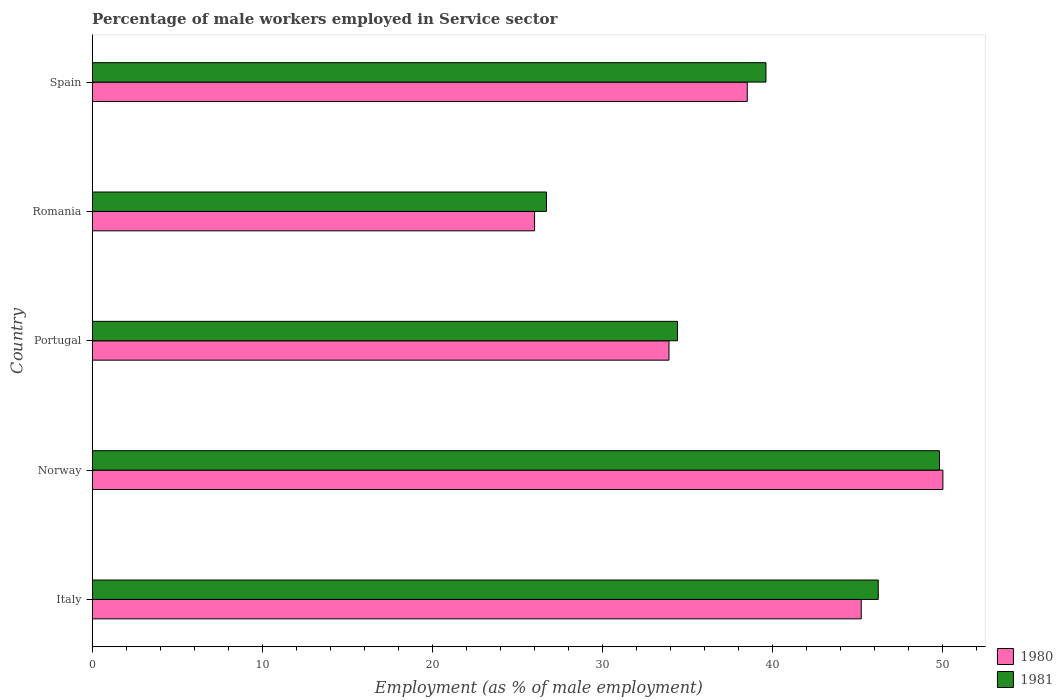How many different coloured bars are there?
Keep it short and to the point. 2. Are the number of bars per tick equal to the number of legend labels?
Offer a very short reply. Yes. How many bars are there on the 3rd tick from the top?
Your answer should be very brief. 2. What is the label of the 3rd group of bars from the top?
Provide a short and direct response. Portugal. In how many cases, is the number of bars for a given country not equal to the number of legend labels?
Ensure brevity in your answer.  0. What is the percentage of male workers employed in Service sector in 1980 in Spain?
Your response must be concise. 38.5. Across all countries, what is the minimum percentage of male workers employed in Service sector in 1980?
Your response must be concise. 26. In which country was the percentage of male workers employed in Service sector in 1981 minimum?
Ensure brevity in your answer.  Romania. What is the total percentage of male workers employed in Service sector in 1980 in the graph?
Ensure brevity in your answer.  193.6. What is the difference between the percentage of male workers employed in Service sector in 1981 in Portugal and that in Romania?
Give a very brief answer. 7.7. What is the difference between the percentage of male workers employed in Service sector in 1981 in Spain and the percentage of male workers employed in Service sector in 1980 in Italy?
Make the answer very short. -5.6. What is the average percentage of male workers employed in Service sector in 1980 per country?
Make the answer very short. 38.72. What is the difference between the percentage of male workers employed in Service sector in 1981 and percentage of male workers employed in Service sector in 1980 in Spain?
Your answer should be very brief. 1.1. In how many countries, is the percentage of male workers employed in Service sector in 1980 greater than 30 %?
Make the answer very short. 4. What is the ratio of the percentage of male workers employed in Service sector in 1980 in Portugal to that in Romania?
Give a very brief answer. 1.3. Is the percentage of male workers employed in Service sector in 1980 in Italy less than that in Spain?
Provide a succinct answer. No. Is the difference between the percentage of male workers employed in Service sector in 1981 in Italy and Norway greater than the difference between the percentage of male workers employed in Service sector in 1980 in Italy and Norway?
Offer a very short reply. Yes. What is the difference between the highest and the second highest percentage of male workers employed in Service sector in 1981?
Your answer should be very brief. 3.6. What is the difference between the highest and the lowest percentage of male workers employed in Service sector in 1981?
Give a very brief answer. 23.1. What does the 1st bar from the top in Italy represents?
Your response must be concise. 1981. What does the 2nd bar from the bottom in Portugal represents?
Give a very brief answer. 1981. Are the values on the major ticks of X-axis written in scientific E-notation?
Offer a very short reply. No. Does the graph contain any zero values?
Give a very brief answer. No. Does the graph contain grids?
Provide a succinct answer. No. What is the title of the graph?
Your response must be concise. Percentage of male workers employed in Service sector. What is the label or title of the X-axis?
Ensure brevity in your answer.  Employment (as % of male employment). What is the label or title of the Y-axis?
Your response must be concise. Country. What is the Employment (as % of male employment) in 1980 in Italy?
Offer a very short reply. 45.2. What is the Employment (as % of male employment) of 1981 in Italy?
Make the answer very short. 46.2. What is the Employment (as % of male employment) of 1981 in Norway?
Your answer should be compact. 49.8. What is the Employment (as % of male employment) in 1980 in Portugal?
Your answer should be very brief. 33.9. What is the Employment (as % of male employment) of 1981 in Portugal?
Keep it short and to the point. 34.4. What is the Employment (as % of male employment) of 1980 in Romania?
Give a very brief answer. 26. What is the Employment (as % of male employment) in 1981 in Romania?
Keep it short and to the point. 26.7. What is the Employment (as % of male employment) in 1980 in Spain?
Offer a terse response. 38.5. What is the Employment (as % of male employment) in 1981 in Spain?
Offer a terse response. 39.6. Across all countries, what is the maximum Employment (as % of male employment) of 1981?
Provide a succinct answer. 49.8. Across all countries, what is the minimum Employment (as % of male employment) in 1981?
Provide a short and direct response. 26.7. What is the total Employment (as % of male employment) of 1980 in the graph?
Ensure brevity in your answer.  193.6. What is the total Employment (as % of male employment) in 1981 in the graph?
Offer a very short reply. 196.7. What is the difference between the Employment (as % of male employment) of 1980 in Italy and that in Portugal?
Your answer should be very brief. 11.3. What is the difference between the Employment (as % of male employment) in 1981 in Italy and that in Portugal?
Offer a very short reply. 11.8. What is the difference between the Employment (as % of male employment) of 1980 in Italy and that in Romania?
Your answer should be compact. 19.2. What is the difference between the Employment (as % of male employment) in 1980 in Norway and that in Portugal?
Provide a succinct answer. 16.1. What is the difference between the Employment (as % of male employment) of 1981 in Norway and that in Portugal?
Your answer should be very brief. 15.4. What is the difference between the Employment (as % of male employment) in 1980 in Norway and that in Romania?
Ensure brevity in your answer.  24. What is the difference between the Employment (as % of male employment) in 1981 in Norway and that in Romania?
Make the answer very short. 23.1. What is the difference between the Employment (as % of male employment) of 1980 in Portugal and that in Romania?
Offer a very short reply. 7.9. What is the difference between the Employment (as % of male employment) of 1981 in Portugal and that in Spain?
Your response must be concise. -5.2. What is the difference between the Employment (as % of male employment) in 1980 in Romania and that in Spain?
Your answer should be very brief. -12.5. What is the difference between the Employment (as % of male employment) of 1981 in Romania and that in Spain?
Keep it short and to the point. -12.9. What is the difference between the Employment (as % of male employment) in 1980 in Italy and the Employment (as % of male employment) in 1981 in Portugal?
Your answer should be compact. 10.8. What is the difference between the Employment (as % of male employment) of 1980 in Italy and the Employment (as % of male employment) of 1981 in Romania?
Offer a terse response. 18.5. What is the difference between the Employment (as % of male employment) in 1980 in Italy and the Employment (as % of male employment) in 1981 in Spain?
Keep it short and to the point. 5.6. What is the difference between the Employment (as % of male employment) in 1980 in Norway and the Employment (as % of male employment) in 1981 in Portugal?
Your answer should be very brief. 15.6. What is the difference between the Employment (as % of male employment) in 1980 in Norway and the Employment (as % of male employment) in 1981 in Romania?
Offer a terse response. 23.3. What is the difference between the Employment (as % of male employment) in 1980 in Portugal and the Employment (as % of male employment) in 1981 in Spain?
Make the answer very short. -5.7. What is the average Employment (as % of male employment) in 1980 per country?
Your answer should be very brief. 38.72. What is the average Employment (as % of male employment) of 1981 per country?
Offer a very short reply. 39.34. What is the difference between the Employment (as % of male employment) of 1980 and Employment (as % of male employment) of 1981 in Spain?
Offer a terse response. -1.1. What is the ratio of the Employment (as % of male employment) in 1980 in Italy to that in Norway?
Provide a short and direct response. 0.9. What is the ratio of the Employment (as % of male employment) of 1981 in Italy to that in Norway?
Keep it short and to the point. 0.93. What is the ratio of the Employment (as % of male employment) in 1981 in Italy to that in Portugal?
Your answer should be very brief. 1.34. What is the ratio of the Employment (as % of male employment) in 1980 in Italy to that in Romania?
Offer a very short reply. 1.74. What is the ratio of the Employment (as % of male employment) of 1981 in Italy to that in Romania?
Give a very brief answer. 1.73. What is the ratio of the Employment (as % of male employment) of 1980 in Italy to that in Spain?
Ensure brevity in your answer.  1.17. What is the ratio of the Employment (as % of male employment) of 1980 in Norway to that in Portugal?
Provide a short and direct response. 1.47. What is the ratio of the Employment (as % of male employment) in 1981 in Norway to that in Portugal?
Ensure brevity in your answer.  1.45. What is the ratio of the Employment (as % of male employment) of 1980 in Norway to that in Romania?
Your answer should be compact. 1.92. What is the ratio of the Employment (as % of male employment) of 1981 in Norway to that in Romania?
Your response must be concise. 1.87. What is the ratio of the Employment (as % of male employment) of 1980 in Norway to that in Spain?
Your answer should be compact. 1.3. What is the ratio of the Employment (as % of male employment) in 1981 in Norway to that in Spain?
Offer a very short reply. 1.26. What is the ratio of the Employment (as % of male employment) of 1980 in Portugal to that in Romania?
Make the answer very short. 1.3. What is the ratio of the Employment (as % of male employment) of 1981 in Portugal to that in Romania?
Offer a very short reply. 1.29. What is the ratio of the Employment (as % of male employment) in 1980 in Portugal to that in Spain?
Your answer should be compact. 0.88. What is the ratio of the Employment (as % of male employment) in 1981 in Portugal to that in Spain?
Offer a terse response. 0.87. What is the ratio of the Employment (as % of male employment) of 1980 in Romania to that in Spain?
Ensure brevity in your answer.  0.68. What is the ratio of the Employment (as % of male employment) in 1981 in Romania to that in Spain?
Ensure brevity in your answer.  0.67. What is the difference between the highest and the second highest Employment (as % of male employment) in 1980?
Offer a very short reply. 4.8. What is the difference between the highest and the second highest Employment (as % of male employment) in 1981?
Your answer should be very brief. 3.6. What is the difference between the highest and the lowest Employment (as % of male employment) in 1981?
Your response must be concise. 23.1. 